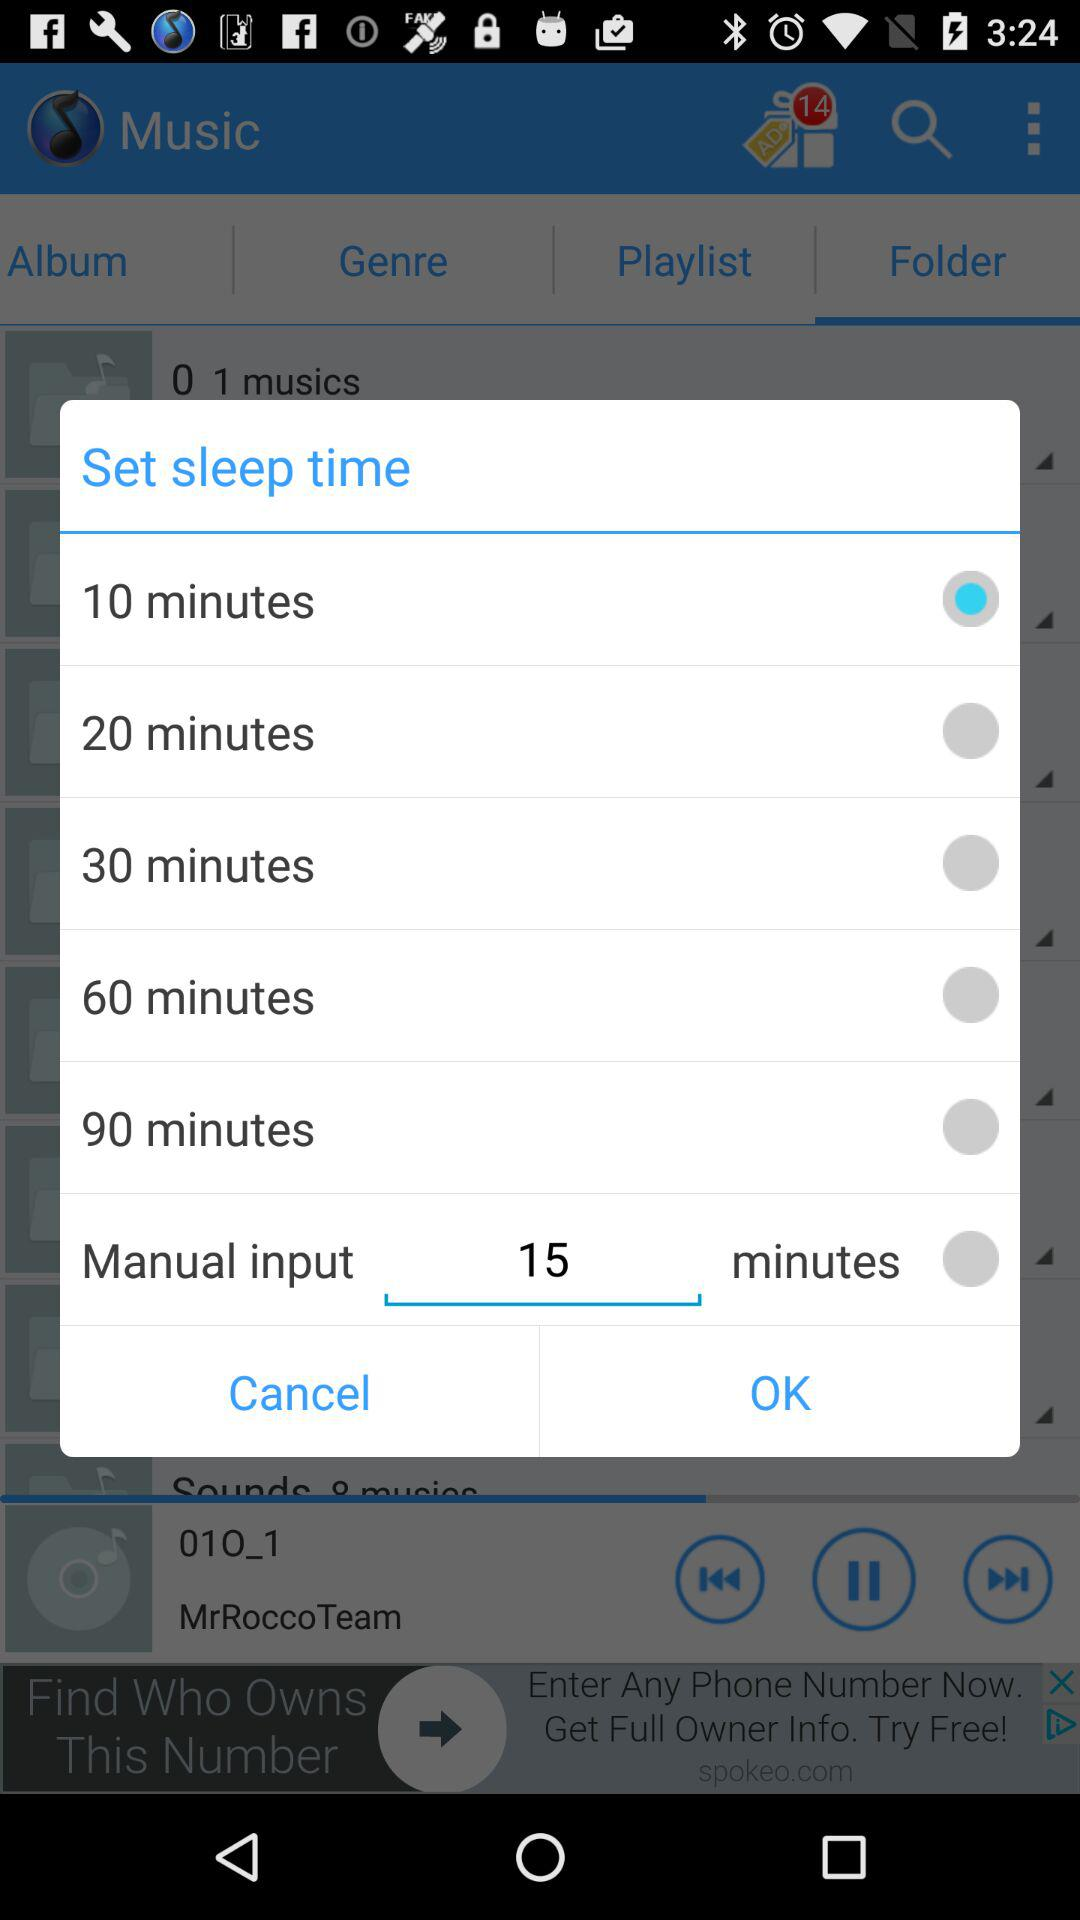What value is entered as manual input? The value entered as manual input is 15. 